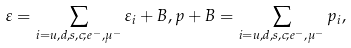Convert formula to latex. <formula><loc_0><loc_0><loc_500><loc_500>\varepsilon = \sum _ { i = u , d , s , c ; e ^ { - } , \mu ^ { - } } \varepsilon _ { i } + B , p + B = \sum _ { i = u , d , s , c ; e ^ { - } , \mu ^ { - } } p _ { i } ,</formula> 